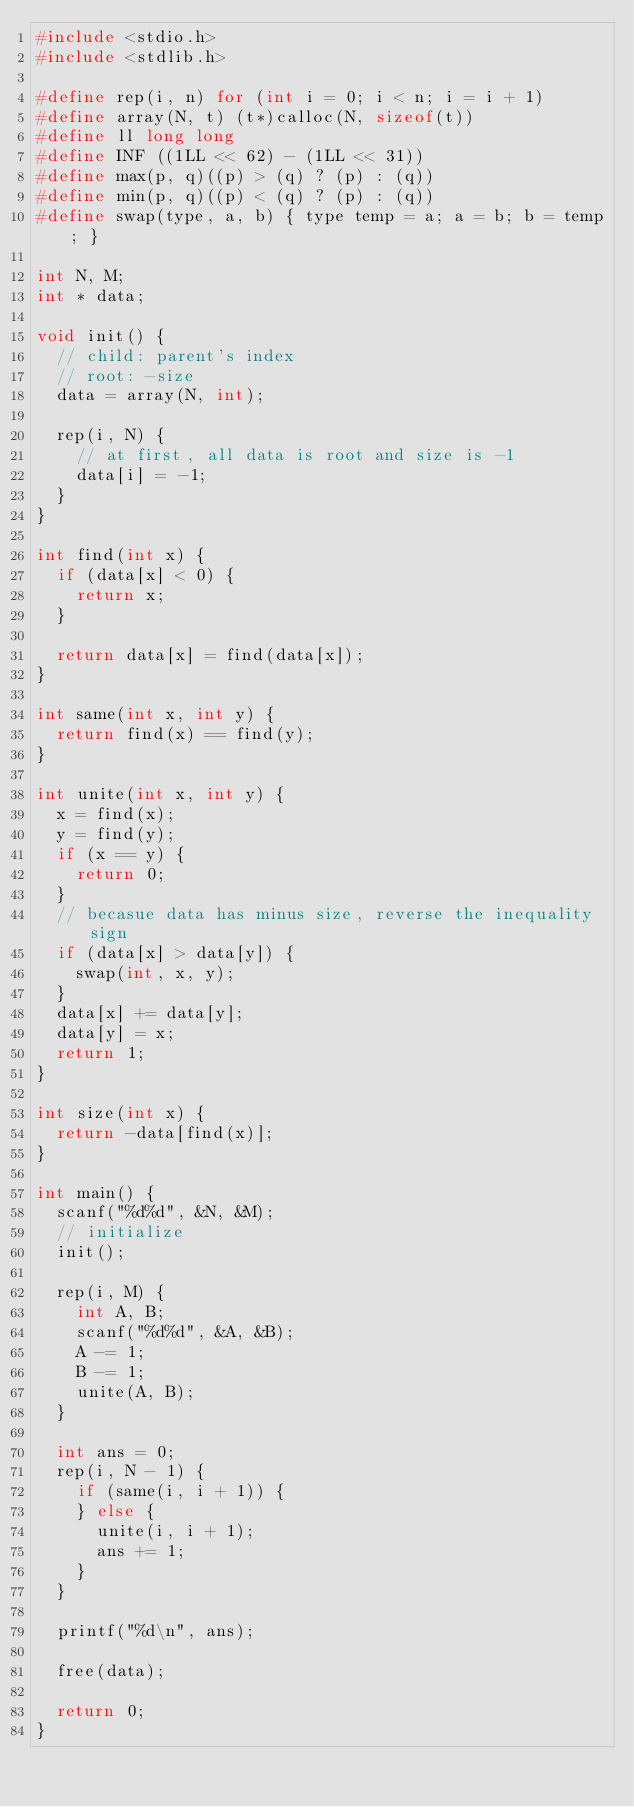Convert code to text. <code><loc_0><loc_0><loc_500><loc_500><_C_>#include <stdio.h>
#include <stdlib.h>

#define rep(i, n) for (int i = 0; i < n; i = i + 1)
#define array(N, t) (t*)calloc(N, sizeof(t))
#define ll long long
#define INF ((1LL << 62) - (1LL << 31))
#define max(p, q)((p) > (q) ? (p) : (q))
#define min(p, q)((p) < (q) ? (p) : (q))
#define swap(type, a, b) { type temp = a; a = b; b = temp; }

int N, M;
int * data;

void init() {
  // child: parent's index
  // root: -size
  data = array(N, int);

  rep(i, N) {
    // at first, all data is root and size is -1
    data[i] = -1;
  }
}

int find(int x) {
  if (data[x] < 0) {
    return x;
  }

  return data[x] = find(data[x]);
}

int same(int x, int y) {
  return find(x) == find(y);
}

int unite(int x, int y) {
  x = find(x);
  y = find(y);
  if (x == y) {
    return 0;
  }
  // becasue data has minus size, reverse the inequality sign
  if (data[x] > data[y]) {
    swap(int, x, y);
  }
  data[x] += data[y];
  data[y] = x;
  return 1;
}

int size(int x) {
  return -data[find(x)];
}

int main() {
  scanf("%d%d", &N, &M);
  // initialize
  init();

  rep(i, M) {
    int A, B;
    scanf("%d%d", &A, &B);
    A -= 1;
    B -= 1;
    unite(A, B);
  }

  int ans = 0;
  rep(i, N - 1) {
    if (same(i, i + 1)) {
    } else {
      unite(i, i + 1);
      ans += 1;
    }
  }

  printf("%d\n", ans);

  free(data);

  return 0;
}
</code> 